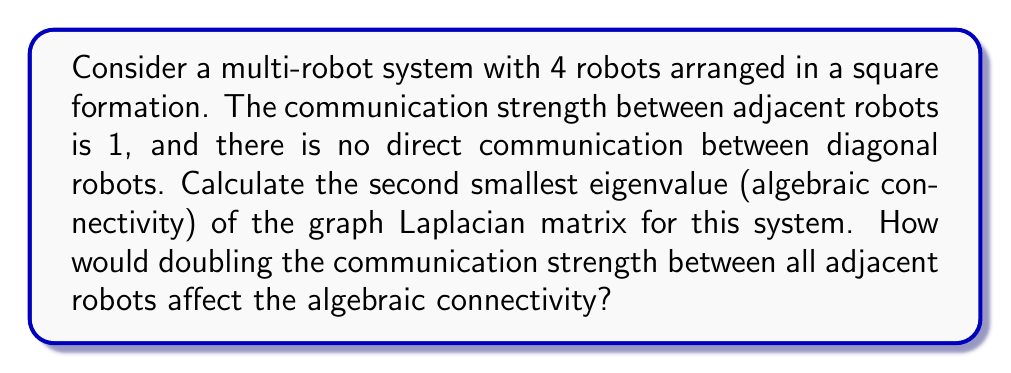Help me with this question. Let's approach this step-by-step:

1) First, we need to construct the adjacency matrix A for the given robot formation:

   $$A = \begin{bmatrix}
   0 & 1 & 0 & 1 \\
   1 & 0 & 1 & 0 \\
   0 & 1 & 0 & 1 \\
   1 & 0 & 1 & 0
   \end{bmatrix}$$

2) Now, we calculate the degree matrix D:

   $$D = \begin{bmatrix}
   2 & 0 & 0 & 0 \\
   0 & 2 & 0 & 0 \\
   0 & 0 & 2 & 0 \\
   0 & 0 & 0 & 2
   \end{bmatrix}$$

3) The graph Laplacian L is given by L = D - A:

   $$L = \begin{bmatrix}
   2 & -1 & 0 & -1 \\
   -1 & 2 & -1 & 0 \\
   0 & -1 & 2 & -1 \\
   -1 & 0 & -1 & 2
   \end{bmatrix}$$

4) To find the eigenvalues, we solve the characteristic equation det(L - λI) = 0:

   $$\begin{vmatrix}
   2-λ & -1 & 0 & -1 \\
   -1 & 2-λ & -1 & 0 \\
   0 & -1 & 2-λ & -1 \\
   -1 & 0 & -1 & 2-λ
   \end{vmatrix} = 0$$

5) Solving this equation gives us the eigenvalues: λ = 0, 2, 2, 4

6) The second smallest eigenvalue (algebraic connectivity) is 2.

7) If we double the communication strength, all non-zero entries in the adjacency matrix A will become 2, and consequently, all non-zero off-diagonal entries in L will become -2, while diagonal entries will become 4.

8) The new Laplacian will be:

   $$L_{new} = \begin{bmatrix}
   4 & -2 & 0 & -2 \\
   -2 & 4 & -2 & 0 \\
   0 & -2 & 4 & -2 \\
   -2 & 0 & -2 & 4
   \end{bmatrix}$$

9) The eigenvalues of this new Laplacian are simply twice the original eigenvalues: 0, 4, 4, 8

10) Therefore, the new algebraic connectivity is 4, which is twice the original value.
Answer: 2; doubles to 4 